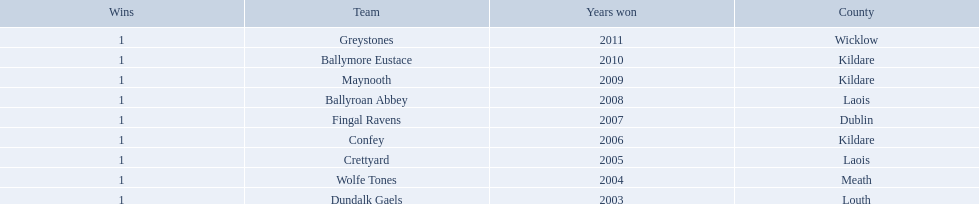Where is ballymore eustace from? Kildare. Would you be able to parse every entry in this table? {'header': ['Wins', 'Team', 'Years won', 'County'], 'rows': [['1', 'Greystones', '2011', 'Wicklow'], ['1', 'Ballymore Eustace', '2010', 'Kildare'], ['1', 'Maynooth', '2009', 'Kildare'], ['1', 'Ballyroan Abbey', '2008', 'Laois'], ['1', 'Fingal Ravens', '2007', 'Dublin'], ['1', 'Confey', '2006', 'Kildare'], ['1', 'Crettyard', '2005', 'Laois'], ['1', 'Wolfe Tones', '2004', 'Meath'], ['1', 'Dundalk Gaels', '2003', 'Louth']]} What teams other than ballymore eustace is from kildare? Maynooth, Confey. Between maynooth and confey, which won in 2009? Maynooth. 